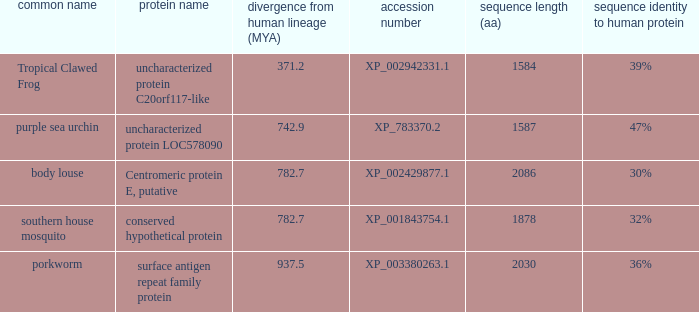What is the sequence length (aa) of the protein with the common name Purple Sea Urchin and a divergence from human lineage less than 742.9? None. 